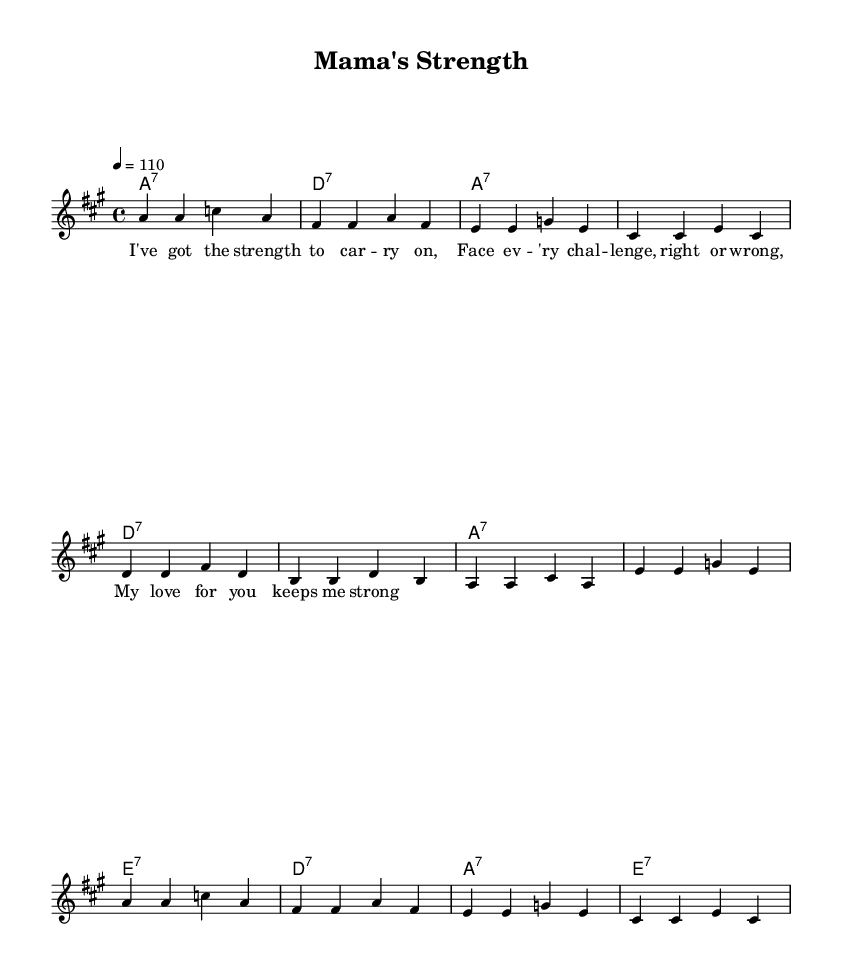What is the key signature of this music? The key signature indicates A major, which has three sharps (F#, C#, G#) according to the global settings in the code.
Answer: A major What is the time signature of this music? The time signature is 4/4, shown in the global settings, which means there are four beats per measure.
Answer: 4/4 What is the tempo marking for this music? The tempo is set to 110 beats per minute, as indicated in the global section with the tempo setting.
Answer: 110 How many measures are there in the melody? By counting the groups between the vertical bars in the melody part, there are a total of 12 measures in the provided melody.
Answer: 12 What are the main chords used in this anthem? The main chords listed in the harmonies include A7, D7, and E7. They are standard chords used in blues progressions, fitting the context of the anthem.
Answer: A7, D7, E7 What is the theme of the lyrics in this piece? The lyrics express empowerment and resilience in facing challenges, emphasizing strength and love, which aligns with the title "Mama's Strength."
Answer: Empowerment Which section of the song contains the lyrics? The lyrics are located in the 'verse' section, defined under the 'lyricmode' with a specific melody assigned to them.
Answer: Verse 